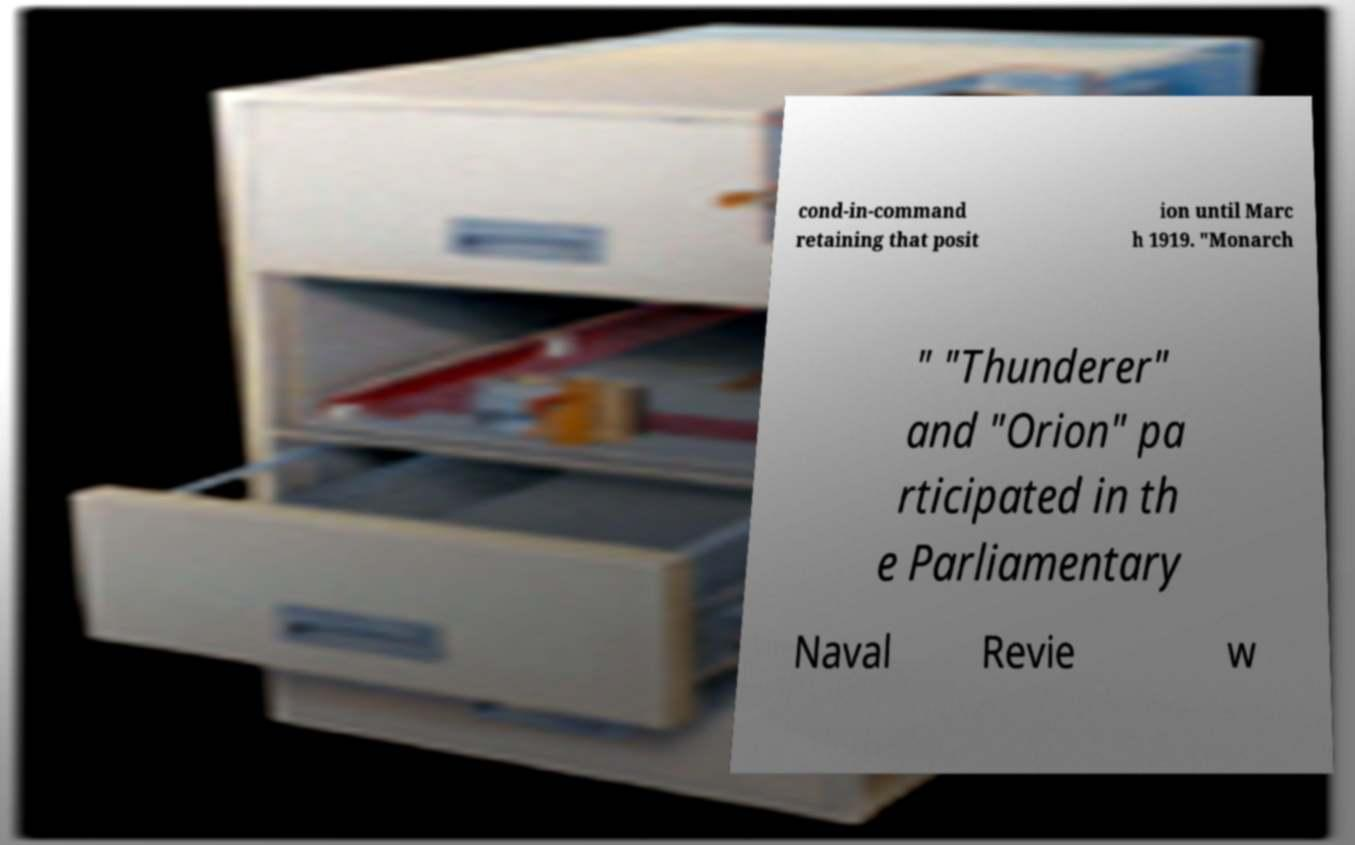I need the written content from this picture converted into text. Can you do that? cond-in-command retaining that posit ion until Marc h 1919. "Monarch " "Thunderer" and "Orion" pa rticipated in th e Parliamentary Naval Revie w 